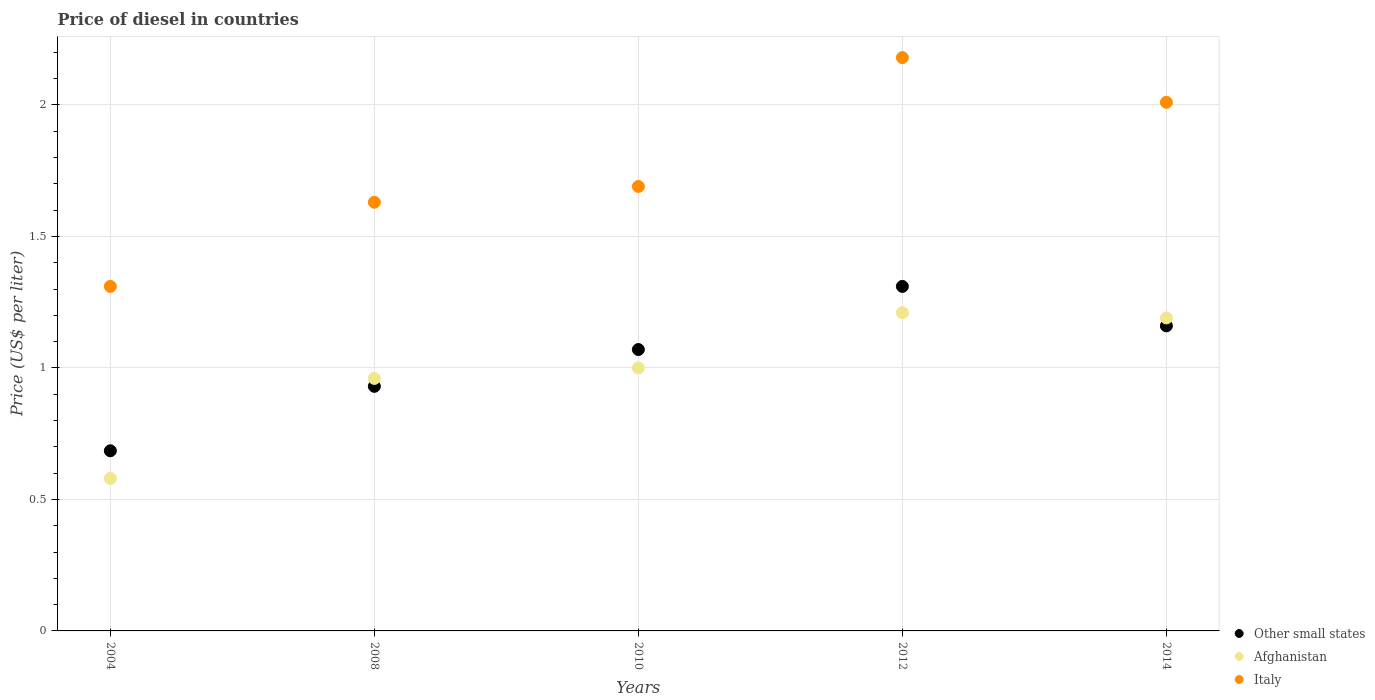How many different coloured dotlines are there?
Make the answer very short. 3. Is the number of dotlines equal to the number of legend labels?
Your answer should be compact. Yes. What is the price of diesel in Italy in 2012?
Offer a terse response. 2.18. Across all years, what is the maximum price of diesel in Other small states?
Your response must be concise. 1.31. Across all years, what is the minimum price of diesel in Italy?
Make the answer very short. 1.31. What is the total price of diesel in Afghanistan in the graph?
Keep it short and to the point. 4.94. What is the difference between the price of diesel in Afghanistan in 2008 and that in 2014?
Provide a succinct answer. -0.23. What is the difference between the price of diesel in Italy in 2014 and the price of diesel in Other small states in 2012?
Provide a short and direct response. 0.7. What is the average price of diesel in Other small states per year?
Offer a very short reply. 1.03. In the year 2010, what is the difference between the price of diesel in Other small states and price of diesel in Italy?
Your answer should be very brief. -0.62. What is the ratio of the price of diesel in Italy in 2012 to that in 2014?
Your answer should be compact. 1.08. Is the price of diesel in Other small states in 2004 less than that in 2010?
Provide a succinct answer. Yes. What is the difference between the highest and the second highest price of diesel in Other small states?
Give a very brief answer. 0.15. What is the difference between the highest and the lowest price of diesel in Afghanistan?
Keep it short and to the point. 0.63. Is the sum of the price of diesel in Other small states in 2008 and 2012 greater than the maximum price of diesel in Italy across all years?
Ensure brevity in your answer.  Yes. Is the price of diesel in Afghanistan strictly greater than the price of diesel in Italy over the years?
Keep it short and to the point. No. Is the price of diesel in Afghanistan strictly less than the price of diesel in Other small states over the years?
Your answer should be very brief. No. What is the difference between two consecutive major ticks on the Y-axis?
Your response must be concise. 0.5. Does the graph contain any zero values?
Offer a very short reply. No. Does the graph contain grids?
Your answer should be compact. Yes. Where does the legend appear in the graph?
Provide a short and direct response. Bottom right. How many legend labels are there?
Your response must be concise. 3. How are the legend labels stacked?
Your answer should be compact. Vertical. What is the title of the graph?
Provide a succinct answer. Price of diesel in countries. Does "Malta" appear as one of the legend labels in the graph?
Your answer should be compact. No. What is the label or title of the Y-axis?
Your answer should be very brief. Price (US$ per liter). What is the Price (US$ per liter) in Other small states in 2004?
Give a very brief answer. 0.69. What is the Price (US$ per liter) in Afghanistan in 2004?
Your answer should be very brief. 0.58. What is the Price (US$ per liter) in Italy in 2004?
Provide a short and direct response. 1.31. What is the Price (US$ per liter) in Afghanistan in 2008?
Offer a terse response. 0.96. What is the Price (US$ per liter) in Italy in 2008?
Your answer should be compact. 1.63. What is the Price (US$ per liter) in Other small states in 2010?
Ensure brevity in your answer.  1.07. What is the Price (US$ per liter) of Italy in 2010?
Provide a short and direct response. 1.69. What is the Price (US$ per liter) of Other small states in 2012?
Your answer should be very brief. 1.31. What is the Price (US$ per liter) in Afghanistan in 2012?
Offer a terse response. 1.21. What is the Price (US$ per liter) in Italy in 2012?
Offer a terse response. 2.18. What is the Price (US$ per liter) in Other small states in 2014?
Give a very brief answer. 1.16. What is the Price (US$ per liter) in Afghanistan in 2014?
Give a very brief answer. 1.19. What is the Price (US$ per liter) of Italy in 2014?
Give a very brief answer. 2.01. Across all years, what is the maximum Price (US$ per liter) in Other small states?
Provide a succinct answer. 1.31. Across all years, what is the maximum Price (US$ per liter) in Afghanistan?
Make the answer very short. 1.21. Across all years, what is the maximum Price (US$ per liter) in Italy?
Ensure brevity in your answer.  2.18. Across all years, what is the minimum Price (US$ per liter) of Other small states?
Keep it short and to the point. 0.69. Across all years, what is the minimum Price (US$ per liter) in Afghanistan?
Give a very brief answer. 0.58. Across all years, what is the minimum Price (US$ per liter) in Italy?
Provide a succinct answer. 1.31. What is the total Price (US$ per liter) in Other small states in the graph?
Your answer should be very brief. 5.16. What is the total Price (US$ per liter) in Afghanistan in the graph?
Ensure brevity in your answer.  4.94. What is the total Price (US$ per liter) in Italy in the graph?
Your answer should be compact. 8.82. What is the difference between the Price (US$ per liter) of Other small states in 2004 and that in 2008?
Keep it short and to the point. -0.24. What is the difference between the Price (US$ per liter) of Afghanistan in 2004 and that in 2008?
Provide a succinct answer. -0.38. What is the difference between the Price (US$ per liter) in Italy in 2004 and that in 2008?
Provide a short and direct response. -0.32. What is the difference between the Price (US$ per liter) in Other small states in 2004 and that in 2010?
Provide a short and direct response. -0.39. What is the difference between the Price (US$ per liter) of Afghanistan in 2004 and that in 2010?
Provide a succinct answer. -0.42. What is the difference between the Price (US$ per liter) of Italy in 2004 and that in 2010?
Provide a short and direct response. -0.38. What is the difference between the Price (US$ per liter) in Other small states in 2004 and that in 2012?
Provide a succinct answer. -0.62. What is the difference between the Price (US$ per liter) of Afghanistan in 2004 and that in 2012?
Keep it short and to the point. -0.63. What is the difference between the Price (US$ per liter) in Italy in 2004 and that in 2012?
Keep it short and to the point. -0.87. What is the difference between the Price (US$ per liter) of Other small states in 2004 and that in 2014?
Provide a short and direct response. -0.47. What is the difference between the Price (US$ per liter) of Afghanistan in 2004 and that in 2014?
Provide a succinct answer. -0.61. What is the difference between the Price (US$ per liter) in Other small states in 2008 and that in 2010?
Offer a terse response. -0.14. What is the difference between the Price (US$ per liter) in Afghanistan in 2008 and that in 2010?
Give a very brief answer. -0.04. What is the difference between the Price (US$ per liter) of Italy in 2008 and that in 2010?
Keep it short and to the point. -0.06. What is the difference between the Price (US$ per liter) in Other small states in 2008 and that in 2012?
Provide a short and direct response. -0.38. What is the difference between the Price (US$ per liter) in Italy in 2008 and that in 2012?
Give a very brief answer. -0.55. What is the difference between the Price (US$ per liter) of Other small states in 2008 and that in 2014?
Your answer should be compact. -0.23. What is the difference between the Price (US$ per liter) of Afghanistan in 2008 and that in 2014?
Provide a short and direct response. -0.23. What is the difference between the Price (US$ per liter) in Italy in 2008 and that in 2014?
Offer a very short reply. -0.38. What is the difference between the Price (US$ per liter) in Other small states in 2010 and that in 2012?
Make the answer very short. -0.24. What is the difference between the Price (US$ per liter) of Afghanistan in 2010 and that in 2012?
Your response must be concise. -0.21. What is the difference between the Price (US$ per liter) of Italy in 2010 and that in 2012?
Your answer should be very brief. -0.49. What is the difference between the Price (US$ per liter) of Other small states in 2010 and that in 2014?
Give a very brief answer. -0.09. What is the difference between the Price (US$ per liter) in Afghanistan in 2010 and that in 2014?
Keep it short and to the point. -0.19. What is the difference between the Price (US$ per liter) in Italy in 2010 and that in 2014?
Give a very brief answer. -0.32. What is the difference between the Price (US$ per liter) of Afghanistan in 2012 and that in 2014?
Your answer should be compact. 0.02. What is the difference between the Price (US$ per liter) of Italy in 2012 and that in 2014?
Your answer should be compact. 0.17. What is the difference between the Price (US$ per liter) of Other small states in 2004 and the Price (US$ per liter) of Afghanistan in 2008?
Your answer should be very brief. -0.28. What is the difference between the Price (US$ per liter) of Other small states in 2004 and the Price (US$ per liter) of Italy in 2008?
Your response must be concise. -0.94. What is the difference between the Price (US$ per liter) of Afghanistan in 2004 and the Price (US$ per liter) of Italy in 2008?
Your answer should be very brief. -1.05. What is the difference between the Price (US$ per liter) in Other small states in 2004 and the Price (US$ per liter) in Afghanistan in 2010?
Your response must be concise. -0.32. What is the difference between the Price (US$ per liter) in Other small states in 2004 and the Price (US$ per liter) in Italy in 2010?
Give a very brief answer. -1. What is the difference between the Price (US$ per liter) in Afghanistan in 2004 and the Price (US$ per liter) in Italy in 2010?
Your answer should be compact. -1.11. What is the difference between the Price (US$ per liter) of Other small states in 2004 and the Price (US$ per liter) of Afghanistan in 2012?
Ensure brevity in your answer.  -0.53. What is the difference between the Price (US$ per liter) in Other small states in 2004 and the Price (US$ per liter) in Italy in 2012?
Provide a short and direct response. -1.5. What is the difference between the Price (US$ per liter) in Afghanistan in 2004 and the Price (US$ per liter) in Italy in 2012?
Your answer should be very brief. -1.6. What is the difference between the Price (US$ per liter) of Other small states in 2004 and the Price (US$ per liter) of Afghanistan in 2014?
Give a very brief answer. -0.51. What is the difference between the Price (US$ per liter) in Other small states in 2004 and the Price (US$ per liter) in Italy in 2014?
Ensure brevity in your answer.  -1.32. What is the difference between the Price (US$ per liter) of Afghanistan in 2004 and the Price (US$ per liter) of Italy in 2014?
Offer a very short reply. -1.43. What is the difference between the Price (US$ per liter) in Other small states in 2008 and the Price (US$ per liter) in Afghanistan in 2010?
Your answer should be very brief. -0.07. What is the difference between the Price (US$ per liter) of Other small states in 2008 and the Price (US$ per liter) of Italy in 2010?
Your answer should be very brief. -0.76. What is the difference between the Price (US$ per liter) in Afghanistan in 2008 and the Price (US$ per liter) in Italy in 2010?
Ensure brevity in your answer.  -0.73. What is the difference between the Price (US$ per liter) of Other small states in 2008 and the Price (US$ per liter) of Afghanistan in 2012?
Offer a terse response. -0.28. What is the difference between the Price (US$ per liter) of Other small states in 2008 and the Price (US$ per liter) of Italy in 2012?
Ensure brevity in your answer.  -1.25. What is the difference between the Price (US$ per liter) of Afghanistan in 2008 and the Price (US$ per liter) of Italy in 2012?
Offer a very short reply. -1.22. What is the difference between the Price (US$ per liter) in Other small states in 2008 and the Price (US$ per liter) in Afghanistan in 2014?
Ensure brevity in your answer.  -0.26. What is the difference between the Price (US$ per liter) in Other small states in 2008 and the Price (US$ per liter) in Italy in 2014?
Offer a very short reply. -1.08. What is the difference between the Price (US$ per liter) in Afghanistan in 2008 and the Price (US$ per liter) in Italy in 2014?
Provide a short and direct response. -1.05. What is the difference between the Price (US$ per liter) of Other small states in 2010 and the Price (US$ per liter) of Afghanistan in 2012?
Give a very brief answer. -0.14. What is the difference between the Price (US$ per liter) in Other small states in 2010 and the Price (US$ per liter) in Italy in 2012?
Provide a short and direct response. -1.11. What is the difference between the Price (US$ per liter) of Afghanistan in 2010 and the Price (US$ per liter) of Italy in 2012?
Give a very brief answer. -1.18. What is the difference between the Price (US$ per liter) in Other small states in 2010 and the Price (US$ per liter) in Afghanistan in 2014?
Offer a very short reply. -0.12. What is the difference between the Price (US$ per liter) in Other small states in 2010 and the Price (US$ per liter) in Italy in 2014?
Your response must be concise. -0.94. What is the difference between the Price (US$ per liter) of Afghanistan in 2010 and the Price (US$ per liter) of Italy in 2014?
Provide a short and direct response. -1.01. What is the difference between the Price (US$ per liter) in Other small states in 2012 and the Price (US$ per liter) in Afghanistan in 2014?
Ensure brevity in your answer.  0.12. What is the average Price (US$ per liter) of Other small states per year?
Keep it short and to the point. 1.03. What is the average Price (US$ per liter) of Italy per year?
Ensure brevity in your answer.  1.76. In the year 2004, what is the difference between the Price (US$ per liter) of Other small states and Price (US$ per liter) of Afghanistan?
Your response must be concise. 0.1. In the year 2004, what is the difference between the Price (US$ per liter) in Other small states and Price (US$ per liter) in Italy?
Offer a very short reply. -0.62. In the year 2004, what is the difference between the Price (US$ per liter) in Afghanistan and Price (US$ per liter) in Italy?
Provide a short and direct response. -0.73. In the year 2008, what is the difference between the Price (US$ per liter) in Other small states and Price (US$ per liter) in Afghanistan?
Make the answer very short. -0.03. In the year 2008, what is the difference between the Price (US$ per liter) in Afghanistan and Price (US$ per liter) in Italy?
Provide a succinct answer. -0.67. In the year 2010, what is the difference between the Price (US$ per liter) in Other small states and Price (US$ per liter) in Afghanistan?
Keep it short and to the point. 0.07. In the year 2010, what is the difference between the Price (US$ per liter) of Other small states and Price (US$ per liter) of Italy?
Your answer should be compact. -0.62. In the year 2010, what is the difference between the Price (US$ per liter) in Afghanistan and Price (US$ per liter) in Italy?
Offer a terse response. -0.69. In the year 2012, what is the difference between the Price (US$ per liter) of Other small states and Price (US$ per liter) of Italy?
Offer a very short reply. -0.87. In the year 2012, what is the difference between the Price (US$ per liter) of Afghanistan and Price (US$ per liter) of Italy?
Keep it short and to the point. -0.97. In the year 2014, what is the difference between the Price (US$ per liter) in Other small states and Price (US$ per liter) in Afghanistan?
Make the answer very short. -0.03. In the year 2014, what is the difference between the Price (US$ per liter) of Other small states and Price (US$ per liter) of Italy?
Keep it short and to the point. -0.85. In the year 2014, what is the difference between the Price (US$ per liter) in Afghanistan and Price (US$ per liter) in Italy?
Your answer should be very brief. -0.82. What is the ratio of the Price (US$ per liter) in Other small states in 2004 to that in 2008?
Your response must be concise. 0.74. What is the ratio of the Price (US$ per liter) of Afghanistan in 2004 to that in 2008?
Give a very brief answer. 0.6. What is the ratio of the Price (US$ per liter) of Italy in 2004 to that in 2008?
Your response must be concise. 0.8. What is the ratio of the Price (US$ per liter) in Other small states in 2004 to that in 2010?
Your response must be concise. 0.64. What is the ratio of the Price (US$ per liter) in Afghanistan in 2004 to that in 2010?
Make the answer very short. 0.58. What is the ratio of the Price (US$ per liter) in Italy in 2004 to that in 2010?
Ensure brevity in your answer.  0.78. What is the ratio of the Price (US$ per liter) in Other small states in 2004 to that in 2012?
Give a very brief answer. 0.52. What is the ratio of the Price (US$ per liter) in Afghanistan in 2004 to that in 2012?
Your answer should be compact. 0.48. What is the ratio of the Price (US$ per liter) in Italy in 2004 to that in 2012?
Make the answer very short. 0.6. What is the ratio of the Price (US$ per liter) of Other small states in 2004 to that in 2014?
Ensure brevity in your answer.  0.59. What is the ratio of the Price (US$ per liter) of Afghanistan in 2004 to that in 2014?
Offer a terse response. 0.49. What is the ratio of the Price (US$ per liter) in Italy in 2004 to that in 2014?
Give a very brief answer. 0.65. What is the ratio of the Price (US$ per liter) in Other small states in 2008 to that in 2010?
Keep it short and to the point. 0.87. What is the ratio of the Price (US$ per liter) in Afghanistan in 2008 to that in 2010?
Offer a very short reply. 0.96. What is the ratio of the Price (US$ per liter) in Italy in 2008 to that in 2010?
Keep it short and to the point. 0.96. What is the ratio of the Price (US$ per liter) in Other small states in 2008 to that in 2012?
Provide a short and direct response. 0.71. What is the ratio of the Price (US$ per liter) in Afghanistan in 2008 to that in 2012?
Make the answer very short. 0.79. What is the ratio of the Price (US$ per liter) of Italy in 2008 to that in 2012?
Give a very brief answer. 0.75. What is the ratio of the Price (US$ per liter) in Other small states in 2008 to that in 2014?
Keep it short and to the point. 0.8. What is the ratio of the Price (US$ per liter) in Afghanistan in 2008 to that in 2014?
Give a very brief answer. 0.81. What is the ratio of the Price (US$ per liter) in Italy in 2008 to that in 2014?
Provide a short and direct response. 0.81. What is the ratio of the Price (US$ per liter) of Other small states in 2010 to that in 2012?
Your answer should be compact. 0.82. What is the ratio of the Price (US$ per liter) in Afghanistan in 2010 to that in 2012?
Provide a succinct answer. 0.83. What is the ratio of the Price (US$ per liter) in Italy in 2010 to that in 2012?
Your answer should be very brief. 0.78. What is the ratio of the Price (US$ per liter) of Other small states in 2010 to that in 2014?
Your answer should be very brief. 0.92. What is the ratio of the Price (US$ per liter) in Afghanistan in 2010 to that in 2014?
Offer a very short reply. 0.84. What is the ratio of the Price (US$ per liter) of Italy in 2010 to that in 2014?
Provide a succinct answer. 0.84. What is the ratio of the Price (US$ per liter) in Other small states in 2012 to that in 2014?
Make the answer very short. 1.13. What is the ratio of the Price (US$ per liter) of Afghanistan in 2012 to that in 2014?
Your answer should be very brief. 1.02. What is the ratio of the Price (US$ per liter) in Italy in 2012 to that in 2014?
Give a very brief answer. 1.08. What is the difference between the highest and the second highest Price (US$ per liter) in Afghanistan?
Give a very brief answer. 0.02. What is the difference between the highest and the second highest Price (US$ per liter) in Italy?
Your answer should be very brief. 0.17. What is the difference between the highest and the lowest Price (US$ per liter) in Afghanistan?
Provide a succinct answer. 0.63. What is the difference between the highest and the lowest Price (US$ per liter) of Italy?
Your answer should be very brief. 0.87. 